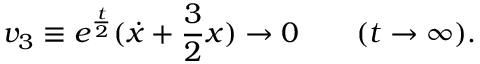<formula> <loc_0><loc_0><loc_500><loc_500>v _ { 3 } \equiv e ^ { \frac { t } { 2 } } ( { \dot { x } } + { \frac { 3 } { 2 } } x ) \rightarrow 0 \quad ( t \rightarrow \infty ) .</formula> 